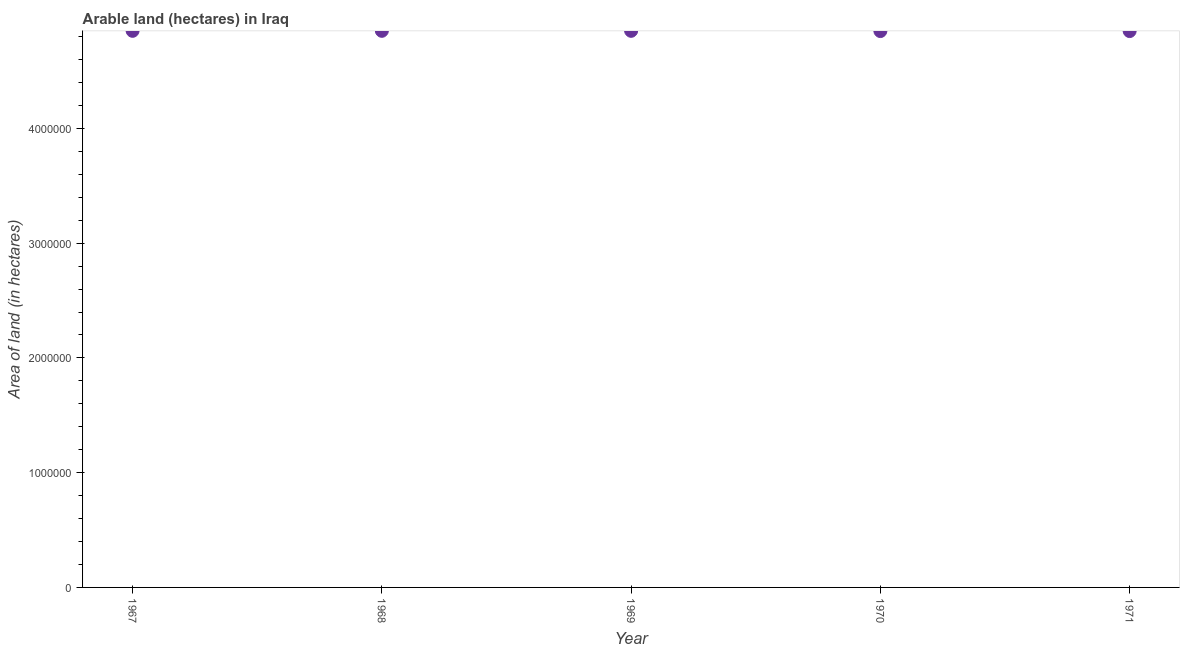What is the area of land in 1969?
Offer a very short reply. 4.85e+06. Across all years, what is the maximum area of land?
Your answer should be compact. 4.85e+06. Across all years, what is the minimum area of land?
Provide a short and direct response. 4.85e+06. In which year was the area of land maximum?
Offer a terse response. 1967. In which year was the area of land minimum?
Provide a succinct answer. 1970. What is the sum of the area of land?
Provide a succinct answer. 2.42e+07. What is the average area of land per year?
Your response must be concise. 4.85e+06. What is the median area of land?
Provide a short and direct response. 4.85e+06. Do a majority of the years between 1969 and 1970 (inclusive) have area of land greater than 1400000 hectares?
Provide a succinct answer. Yes. What is the ratio of the area of land in 1968 to that in 1970?
Your response must be concise. 1. What is the difference between the highest and the lowest area of land?
Provide a succinct answer. 2000. In how many years, is the area of land greater than the average area of land taken over all years?
Your response must be concise. 3. Does the graph contain any zero values?
Offer a terse response. No. What is the title of the graph?
Keep it short and to the point. Arable land (hectares) in Iraq. What is the label or title of the X-axis?
Keep it short and to the point. Year. What is the label or title of the Y-axis?
Make the answer very short. Area of land (in hectares). What is the Area of land (in hectares) in 1967?
Your answer should be very brief. 4.85e+06. What is the Area of land (in hectares) in 1968?
Provide a short and direct response. 4.85e+06. What is the Area of land (in hectares) in 1969?
Offer a terse response. 4.85e+06. What is the Area of land (in hectares) in 1970?
Make the answer very short. 4.85e+06. What is the Area of land (in hectares) in 1971?
Give a very brief answer. 4.85e+06. What is the difference between the Area of land (in hectares) in 1967 and 1968?
Offer a terse response. 0. What is the difference between the Area of land (in hectares) in 1967 and 1969?
Your answer should be compact. 0. What is the difference between the Area of land (in hectares) in 1968 and 1969?
Provide a short and direct response. 0. What is the difference between the Area of land (in hectares) in 1969 and 1970?
Your answer should be very brief. 2000. What is the difference between the Area of land (in hectares) in 1969 and 1971?
Your response must be concise. 2000. What is the ratio of the Area of land (in hectares) in 1967 to that in 1970?
Keep it short and to the point. 1. What is the ratio of the Area of land (in hectares) in 1968 to that in 1970?
Offer a terse response. 1. What is the ratio of the Area of land (in hectares) in 1969 to that in 1970?
Provide a succinct answer. 1. What is the ratio of the Area of land (in hectares) in 1969 to that in 1971?
Your answer should be very brief. 1. 